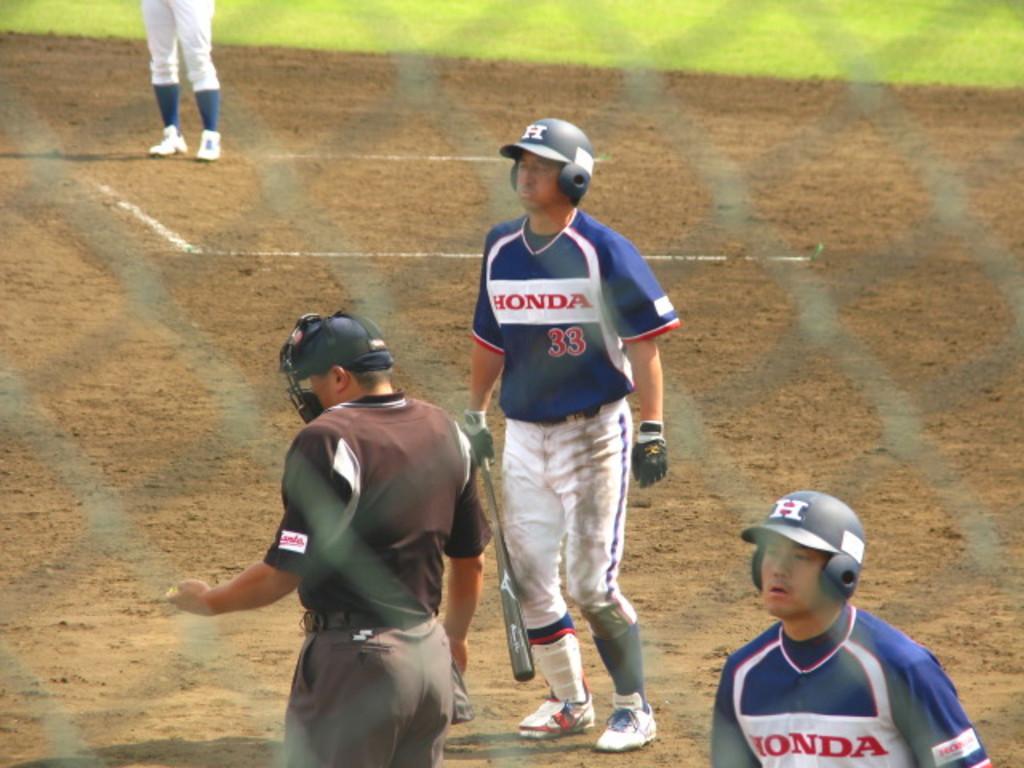Please provide a concise description of this image. In this image we can see a net. In the background we can see few persons and a person among them is holding a baseball bat in the hand, grass on the ground and we can see a person´s legs on the ground. 